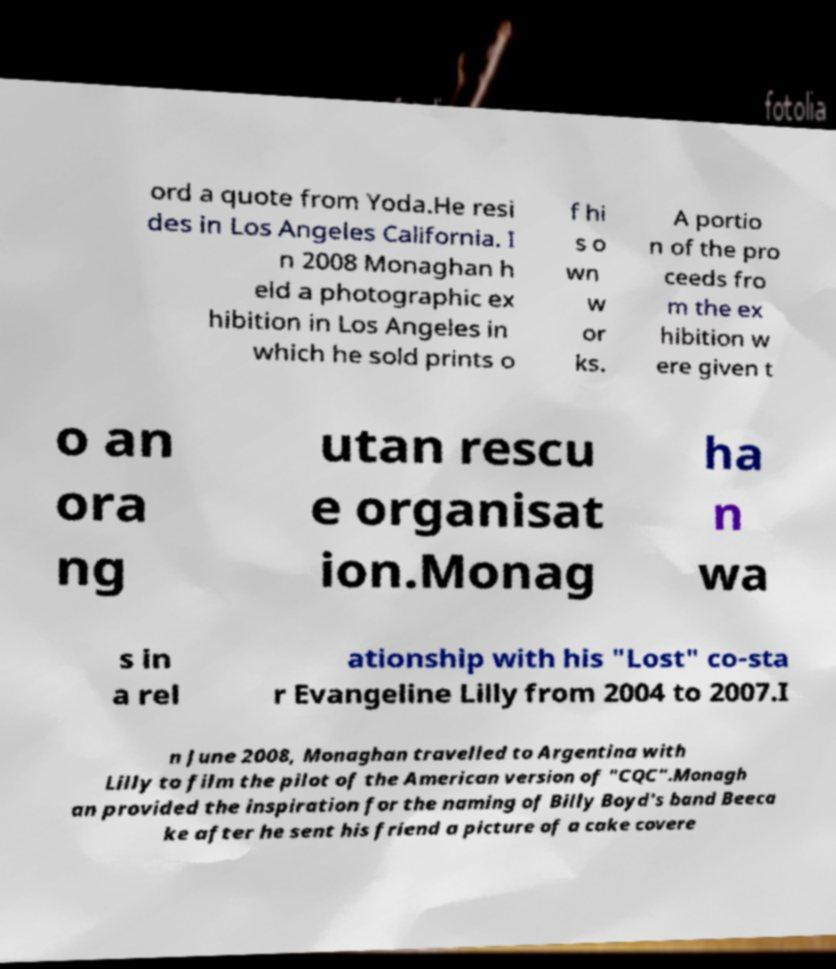Can you read and provide the text displayed in the image?This photo seems to have some interesting text. Can you extract and type it out for me? ord a quote from Yoda.He resi des in Los Angeles California. I n 2008 Monaghan h eld a photographic ex hibition in Los Angeles in which he sold prints o f hi s o wn w or ks. A portio n of the pro ceeds fro m the ex hibition w ere given t o an ora ng utan rescu e organisat ion.Monag ha n wa s in a rel ationship with his "Lost" co-sta r Evangeline Lilly from 2004 to 2007.I n June 2008, Monaghan travelled to Argentina with Lilly to film the pilot of the American version of "CQC".Monagh an provided the inspiration for the naming of Billy Boyd's band Beeca ke after he sent his friend a picture of a cake covere 